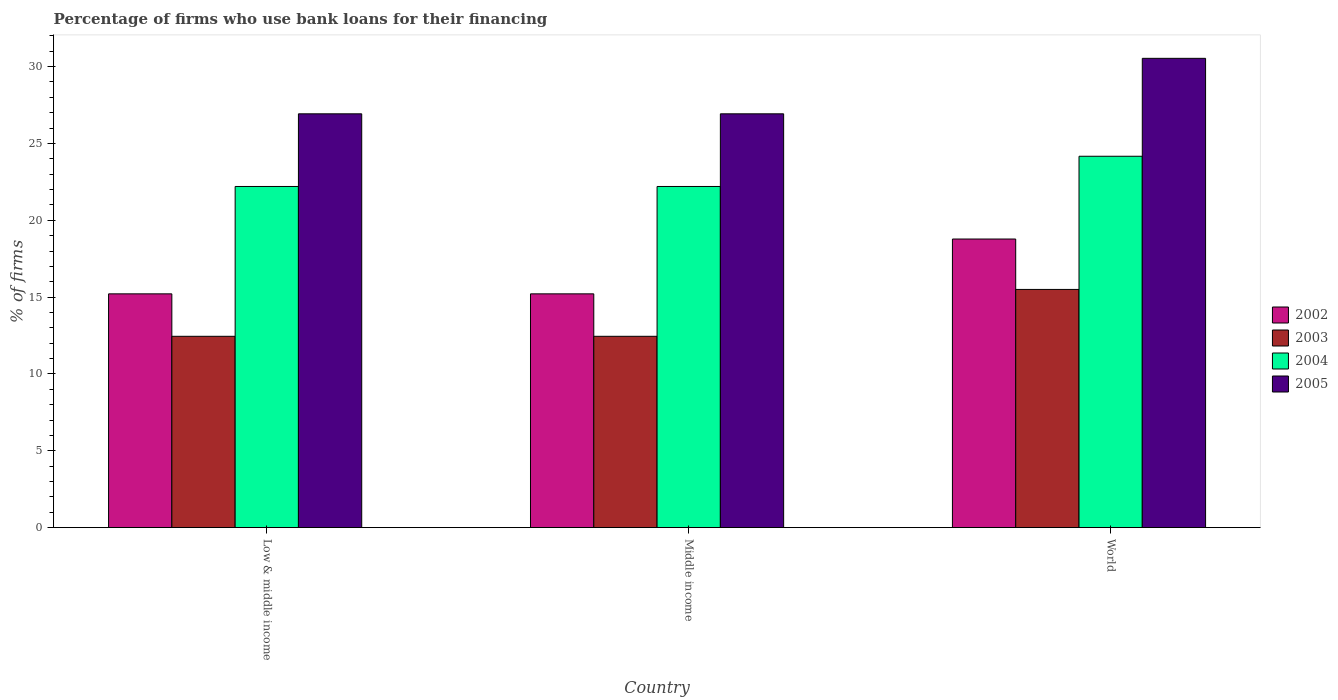Are the number of bars per tick equal to the number of legend labels?
Provide a succinct answer. Yes. In how many cases, is the number of bars for a given country not equal to the number of legend labels?
Your answer should be very brief. 0. What is the percentage of firms who use bank loans for their financing in 2005 in World?
Give a very brief answer. 30.54. Across all countries, what is the maximum percentage of firms who use bank loans for their financing in 2005?
Ensure brevity in your answer.  30.54. Across all countries, what is the minimum percentage of firms who use bank loans for their financing in 2002?
Give a very brief answer. 15.21. In which country was the percentage of firms who use bank loans for their financing in 2005 minimum?
Give a very brief answer. Low & middle income. What is the total percentage of firms who use bank loans for their financing in 2004 in the graph?
Keep it short and to the point. 68.57. What is the difference between the percentage of firms who use bank loans for their financing in 2003 in Low & middle income and that in Middle income?
Offer a terse response. 0. What is the difference between the percentage of firms who use bank loans for their financing in 2005 in World and the percentage of firms who use bank loans for their financing in 2003 in Middle income?
Make the answer very short. 18.09. What is the average percentage of firms who use bank loans for their financing in 2005 per country?
Offer a terse response. 28.13. What is the difference between the percentage of firms who use bank loans for their financing of/in 2002 and percentage of firms who use bank loans for their financing of/in 2004 in Low & middle income?
Your response must be concise. -6.99. In how many countries, is the percentage of firms who use bank loans for their financing in 2002 greater than 18 %?
Provide a short and direct response. 1. What is the ratio of the percentage of firms who use bank loans for their financing in 2003 in Low & middle income to that in World?
Provide a short and direct response. 0.8. Is the percentage of firms who use bank loans for their financing in 2005 in Low & middle income less than that in Middle income?
Offer a very short reply. No. What is the difference between the highest and the second highest percentage of firms who use bank loans for their financing in 2003?
Your answer should be very brief. -3.05. What is the difference between the highest and the lowest percentage of firms who use bank loans for their financing in 2004?
Offer a very short reply. 1.97. Is the sum of the percentage of firms who use bank loans for their financing in 2005 in Middle income and World greater than the maximum percentage of firms who use bank loans for their financing in 2002 across all countries?
Your response must be concise. Yes. Is it the case that in every country, the sum of the percentage of firms who use bank loans for their financing in 2003 and percentage of firms who use bank loans for their financing in 2002 is greater than the sum of percentage of firms who use bank loans for their financing in 2004 and percentage of firms who use bank loans for their financing in 2005?
Ensure brevity in your answer.  No. What does the 3rd bar from the left in World represents?
Keep it short and to the point. 2004. What does the 4th bar from the right in Low & middle income represents?
Provide a short and direct response. 2002. Is it the case that in every country, the sum of the percentage of firms who use bank loans for their financing in 2004 and percentage of firms who use bank loans for their financing in 2005 is greater than the percentage of firms who use bank loans for their financing in 2003?
Offer a very short reply. Yes. How many bars are there?
Your answer should be very brief. 12. Are all the bars in the graph horizontal?
Ensure brevity in your answer.  No. What is the difference between two consecutive major ticks on the Y-axis?
Your response must be concise. 5. Does the graph contain any zero values?
Keep it short and to the point. No. Where does the legend appear in the graph?
Ensure brevity in your answer.  Center right. How are the legend labels stacked?
Your response must be concise. Vertical. What is the title of the graph?
Offer a very short reply. Percentage of firms who use bank loans for their financing. What is the label or title of the Y-axis?
Provide a short and direct response. % of firms. What is the % of firms in 2002 in Low & middle income?
Provide a short and direct response. 15.21. What is the % of firms of 2003 in Low & middle income?
Ensure brevity in your answer.  12.45. What is the % of firms in 2004 in Low & middle income?
Ensure brevity in your answer.  22.2. What is the % of firms in 2005 in Low & middle income?
Offer a very short reply. 26.93. What is the % of firms of 2002 in Middle income?
Provide a succinct answer. 15.21. What is the % of firms of 2003 in Middle income?
Give a very brief answer. 12.45. What is the % of firms in 2004 in Middle income?
Your answer should be very brief. 22.2. What is the % of firms of 2005 in Middle income?
Keep it short and to the point. 26.93. What is the % of firms of 2002 in World?
Give a very brief answer. 18.78. What is the % of firms of 2003 in World?
Provide a short and direct response. 15.5. What is the % of firms of 2004 in World?
Provide a succinct answer. 24.17. What is the % of firms of 2005 in World?
Offer a terse response. 30.54. Across all countries, what is the maximum % of firms of 2002?
Make the answer very short. 18.78. Across all countries, what is the maximum % of firms in 2004?
Offer a terse response. 24.17. Across all countries, what is the maximum % of firms of 2005?
Your answer should be very brief. 30.54. Across all countries, what is the minimum % of firms of 2002?
Your response must be concise. 15.21. Across all countries, what is the minimum % of firms in 2003?
Keep it short and to the point. 12.45. Across all countries, what is the minimum % of firms in 2005?
Your answer should be compact. 26.93. What is the total % of firms in 2002 in the graph?
Your response must be concise. 49.21. What is the total % of firms of 2003 in the graph?
Provide a succinct answer. 40.4. What is the total % of firms in 2004 in the graph?
Make the answer very short. 68.57. What is the total % of firms in 2005 in the graph?
Your answer should be very brief. 84.39. What is the difference between the % of firms in 2003 in Low & middle income and that in Middle income?
Give a very brief answer. 0. What is the difference between the % of firms in 2002 in Low & middle income and that in World?
Your answer should be very brief. -3.57. What is the difference between the % of firms in 2003 in Low & middle income and that in World?
Provide a short and direct response. -3.05. What is the difference between the % of firms of 2004 in Low & middle income and that in World?
Make the answer very short. -1.97. What is the difference between the % of firms of 2005 in Low & middle income and that in World?
Your answer should be compact. -3.61. What is the difference between the % of firms of 2002 in Middle income and that in World?
Offer a very short reply. -3.57. What is the difference between the % of firms in 2003 in Middle income and that in World?
Offer a terse response. -3.05. What is the difference between the % of firms of 2004 in Middle income and that in World?
Give a very brief answer. -1.97. What is the difference between the % of firms of 2005 in Middle income and that in World?
Ensure brevity in your answer.  -3.61. What is the difference between the % of firms of 2002 in Low & middle income and the % of firms of 2003 in Middle income?
Make the answer very short. 2.76. What is the difference between the % of firms of 2002 in Low & middle income and the % of firms of 2004 in Middle income?
Provide a short and direct response. -6.99. What is the difference between the % of firms in 2002 in Low & middle income and the % of firms in 2005 in Middle income?
Your response must be concise. -11.72. What is the difference between the % of firms of 2003 in Low & middle income and the % of firms of 2004 in Middle income?
Make the answer very short. -9.75. What is the difference between the % of firms in 2003 in Low & middle income and the % of firms in 2005 in Middle income?
Keep it short and to the point. -14.48. What is the difference between the % of firms of 2004 in Low & middle income and the % of firms of 2005 in Middle income?
Ensure brevity in your answer.  -4.73. What is the difference between the % of firms of 2002 in Low & middle income and the % of firms of 2003 in World?
Keep it short and to the point. -0.29. What is the difference between the % of firms of 2002 in Low & middle income and the % of firms of 2004 in World?
Offer a very short reply. -8.95. What is the difference between the % of firms of 2002 in Low & middle income and the % of firms of 2005 in World?
Make the answer very short. -15.33. What is the difference between the % of firms of 2003 in Low & middle income and the % of firms of 2004 in World?
Your response must be concise. -11.72. What is the difference between the % of firms in 2003 in Low & middle income and the % of firms in 2005 in World?
Offer a very short reply. -18.09. What is the difference between the % of firms of 2004 in Low & middle income and the % of firms of 2005 in World?
Give a very brief answer. -8.34. What is the difference between the % of firms in 2002 in Middle income and the % of firms in 2003 in World?
Your response must be concise. -0.29. What is the difference between the % of firms of 2002 in Middle income and the % of firms of 2004 in World?
Keep it short and to the point. -8.95. What is the difference between the % of firms in 2002 in Middle income and the % of firms in 2005 in World?
Provide a short and direct response. -15.33. What is the difference between the % of firms in 2003 in Middle income and the % of firms in 2004 in World?
Keep it short and to the point. -11.72. What is the difference between the % of firms in 2003 in Middle income and the % of firms in 2005 in World?
Make the answer very short. -18.09. What is the difference between the % of firms of 2004 in Middle income and the % of firms of 2005 in World?
Offer a very short reply. -8.34. What is the average % of firms in 2002 per country?
Give a very brief answer. 16.4. What is the average % of firms in 2003 per country?
Give a very brief answer. 13.47. What is the average % of firms of 2004 per country?
Your answer should be very brief. 22.86. What is the average % of firms of 2005 per country?
Your answer should be very brief. 28.13. What is the difference between the % of firms of 2002 and % of firms of 2003 in Low & middle income?
Offer a terse response. 2.76. What is the difference between the % of firms of 2002 and % of firms of 2004 in Low & middle income?
Give a very brief answer. -6.99. What is the difference between the % of firms in 2002 and % of firms in 2005 in Low & middle income?
Your answer should be very brief. -11.72. What is the difference between the % of firms in 2003 and % of firms in 2004 in Low & middle income?
Your answer should be compact. -9.75. What is the difference between the % of firms of 2003 and % of firms of 2005 in Low & middle income?
Your answer should be compact. -14.48. What is the difference between the % of firms of 2004 and % of firms of 2005 in Low & middle income?
Offer a very short reply. -4.73. What is the difference between the % of firms in 2002 and % of firms in 2003 in Middle income?
Make the answer very short. 2.76. What is the difference between the % of firms in 2002 and % of firms in 2004 in Middle income?
Offer a terse response. -6.99. What is the difference between the % of firms in 2002 and % of firms in 2005 in Middle income?
Make the answer very short. -11.72. What is the difference between the % of firms in 2003 and % of firms in 2004 in Middle income?
Offer a very short reply. -9.75. What is the difference between the % of firms of 2003 and % of firms of 2005 in Middle income?
Keep it short and to the point. -14.48. What is the difference between the % of firms of 2004 and % of firms of 2005 in Middle income?
Give a very brief answer. -4.73. What is the difference between the % of firms in 2002 and % of firms in 2003 in World?
Your answer should be compact. 3.28. What is the difference between the % of firms in 2002 and % of firms in 2004 in World?
Your response must be concise. -5.39. What is the difference between the % of firms in 2002 and % of firms in 2005 in World?
Your answer should be compact. -11.76. What is the difference between the % of firms in 2003 and % of firms in 2004 in World?
Offer a very short reply. -8.67. What is the difference between the % of firms of 2003 and % of firms of 2005 in World?
Make the answer very short. -15.04. What is the difference between the % of firms in 2004 and % of firms in 2005 in World?
Provide a short and direct response. -6.37. What is the ratio of the % of firms in 2002 in Low & middle income to that in Middle income?
Your response must be concise. 1. What is the ratio of the % of firms of 2002 in Low & middle income to that in World?
Offer a terse response. 0.81. What is the ratio of the % of firms in 2003 in Low & middle income to that in World?
Your response must be concise. 0.8. What is the ratio of the % of firms of 2004 in Low & middle income to that in World?
Your answer should be compact. 0.92. What is the ratio of the % of firms of 2005 in Low & middle income to that in World?
Offer a very short reply. 0.88. What is the ratio of the % of firms of 2002 in Middle income to that in World?
Offer a very short reply. 0.81. What is the ratio of the % of firms in 2003 in Middle income to that in World?
Ensure brevity in your answer.  0.8. What is the ratio of the % of firms in 2004 in Middle income to that in World?
Give a very brief answer. 0.92. What is the ratio of the % of firms of 2005 in Middle income to that in World?
Offer a terse response. 0.88. What is the difference between the highest and the second highest % of firms in 2002?
Give a very brief answer. 3.57. What is the difference between the highest and the second highest % of firms in 2003?
Ensure brevity in your answer.  3.05. What is the difference between the highest and the second highest % of firms in 2004?
Your response must be concise. 1.97. What is the difference between the highest and the second highest % of firms in 2005?
Your response must be concise. 3.61. What is the difference between the highest and the lowest % of firms of 2002?
Your answer should be very brief. 3.57. What is the difference between the highest and the lowest % of firms of 2003?
Offer a very short reply. 3.05. What is the difference between the highest and the lowest % of firms of 2004?
Your answer should be very brief. 1.97. What is the difference between the highest and the lowest % of firms in 2005?
Your answer should be compact. 3.61. 